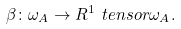<formula> <loc_0><loc_0><loc_500><loc_500>\beta \colon \omega _ { A } \to R ^ { 1 } \ t e n s o r \omega _ { A } .</formula> 